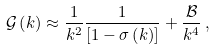Convert formula to latex. <formula><loc_0><loc_0><loc_500><loc_500>\mathcal { G } \left ( k \right ) \approx \frac { 1 } { k ^ { 2 } } \frac { 1 } { \left [ 1 - \sigma \left ( k \right ) \right ] } + \frac { \mathcal { B } } { k ^ { 4 } } \, ,</formula> 